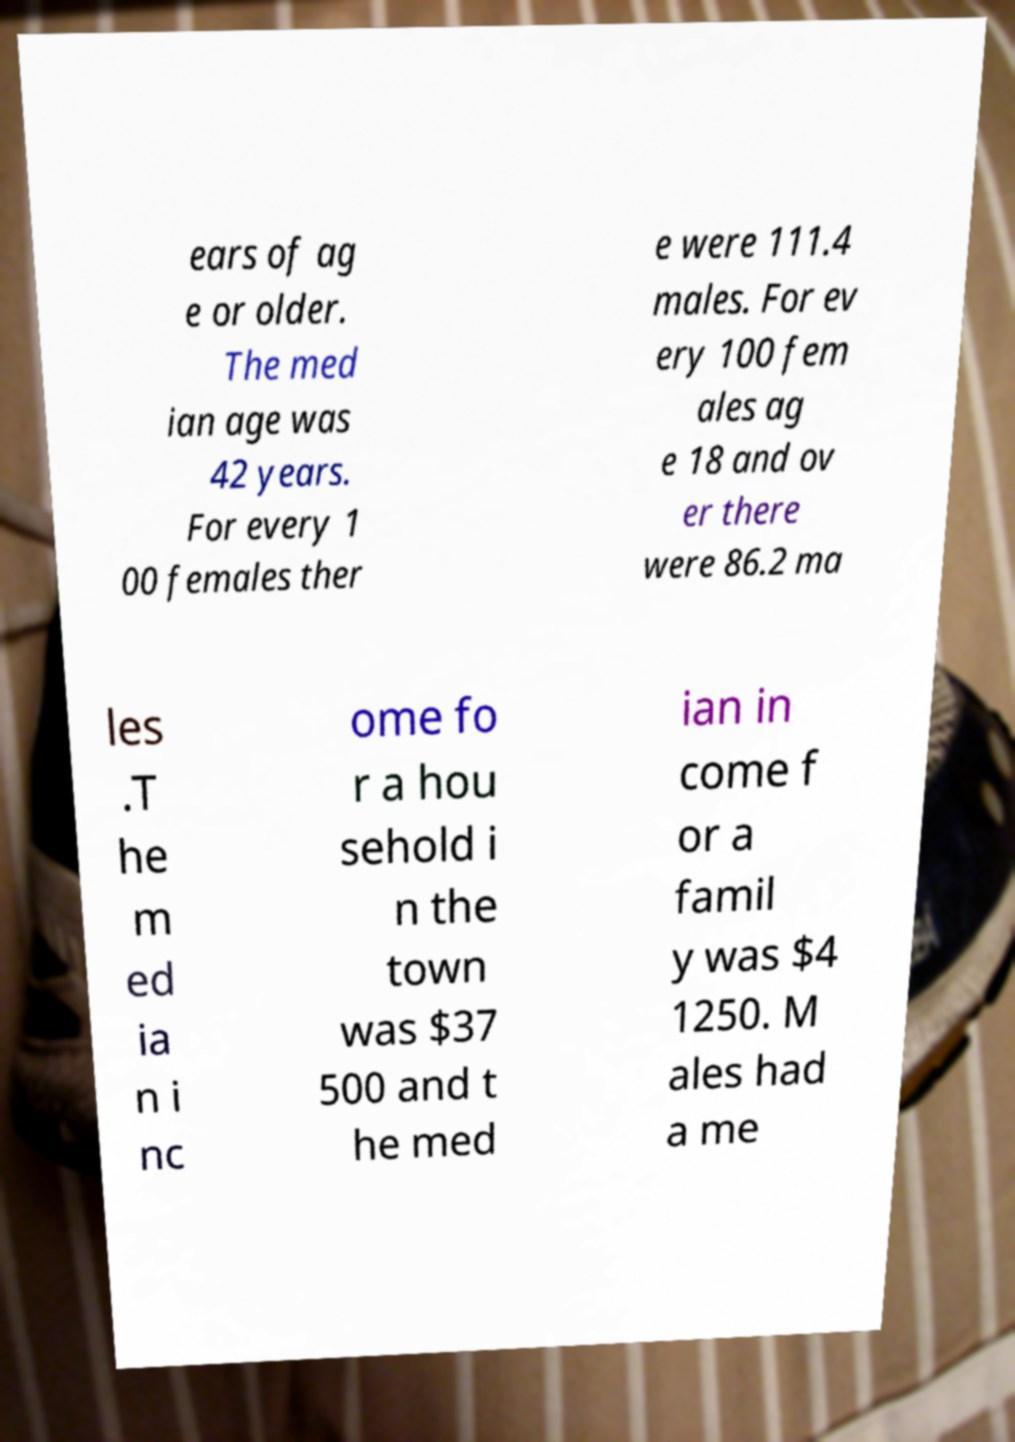Could you assist in decoding the text presented in this image and type it out clearly? ears of ag e or older. The med ian age was 42 years. For every 1 00 females ther e were 111.4 males. For ev ery 100 fem ales ag e 18 and ov er there were 86.2 ma les .T he m ed ia n i nc ome fo r a hou sehold i n the town was $37 500 and t he med ian in come f or a famil y was $4 1250. M ales had a me 